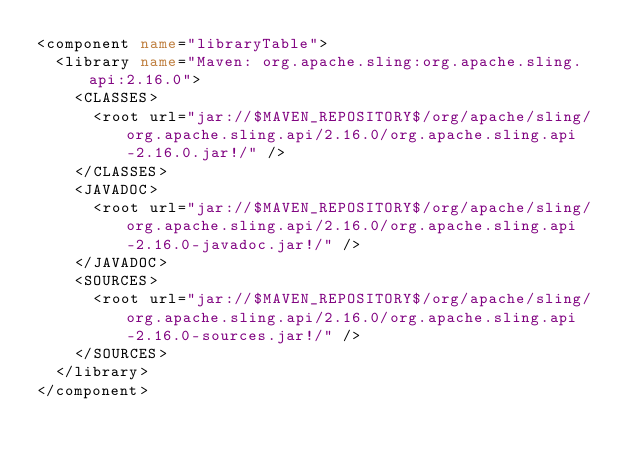<code> <loc_0><loc_0><loc_500><loc_500><_XML_><component name="libraryTable">
  <library name="Maven: org.apache.sling:org.apache.sling.api:2.16.0">
    <CLASSES>
      <root url="jar://$MAVEN_REPOSITORY$/org/apache/sling/org.apache.sling.api/2.16.0/org.apache.sling.api-2.16.0.jar!/" />
    </CLASSES>
    <JAVADOC>
      <root url="jar://$MAVEN_REPOSITORY$/org/apache/sling/org.apache.sling.api/2.16.0/org.apache.sling.api-2.16.0-javadoc.jar!/" />
    </JAVADOC>
    <SOURCES>
      <root url="jar://$MAVEN_REPOSITORY$/org/apache/sling/org.apache.sling.api/2.16.0/org.apache.sling.api-2.16.0-sources.jar!/" />
    </SOURCES>
  </library>
</component></code> 